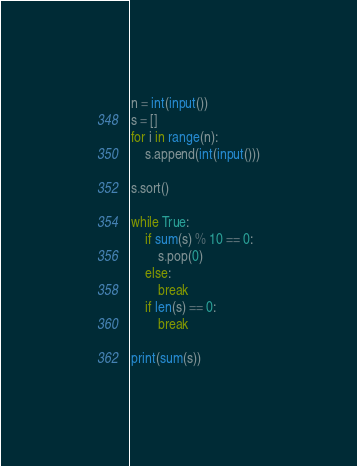<code> <loc_0><loc_0><loc_500><loc_500><_Python_>n = int(input())
s = []
for i in range(n):
    s.append(int(input()))

s.sort()

while True:
    if sum(s) % 10 == 0:
        s.pop(0)
    else:
        break
    if len(s) == 0:
        break
    
print(sum(s))
</code> 